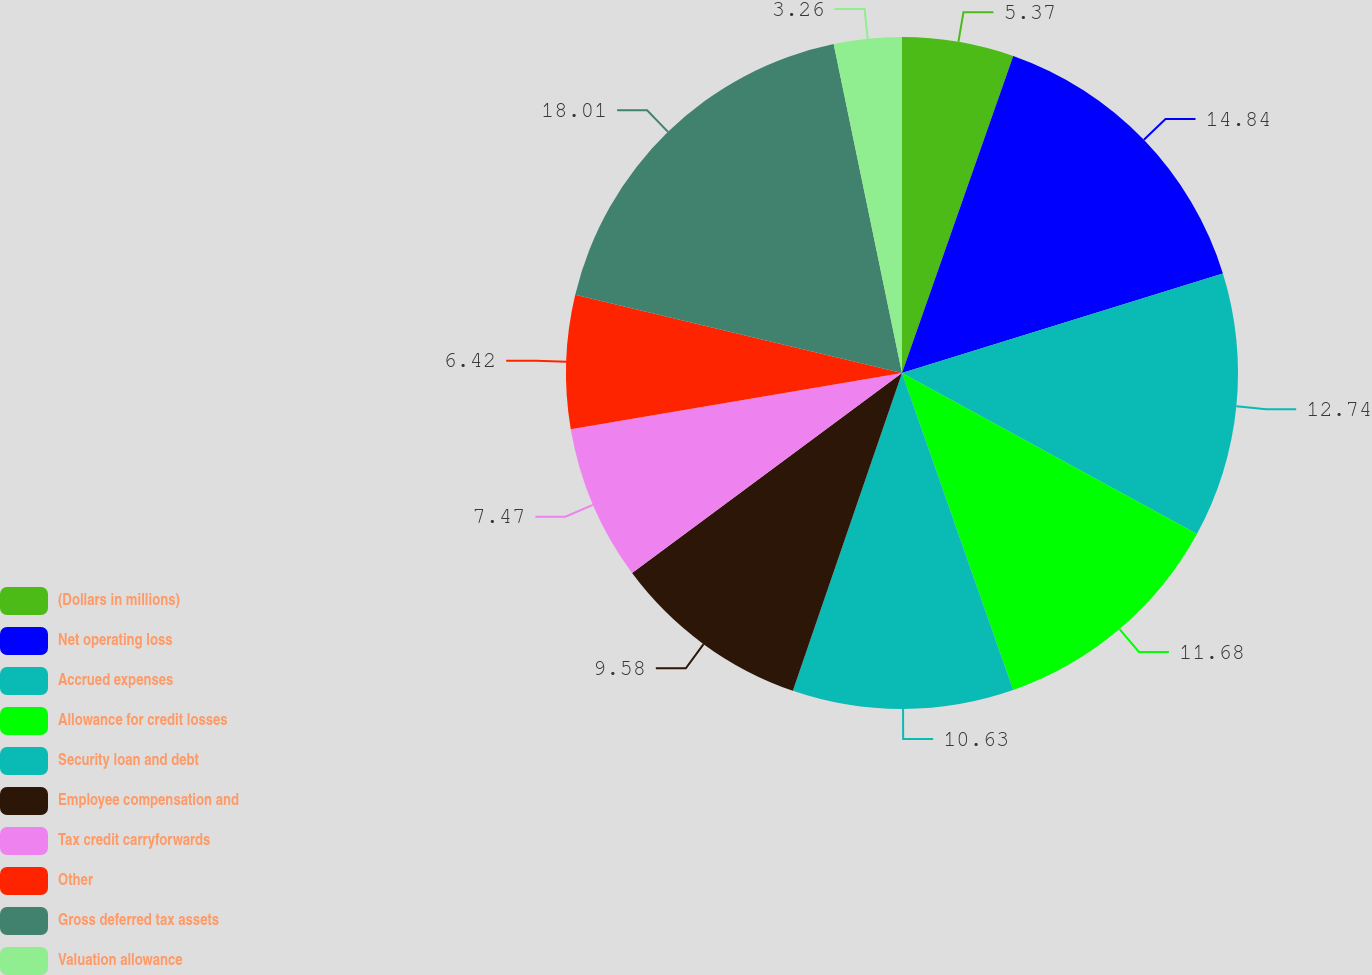<chart> <loc_0><loc_0><loc_500><loc_500><pie_chart><fcel>(Dollars in millions)<fcel>Net operating loss<fcel>Accrued expenses<fcel>Allowance for credit losses<fcel>Security loan and debt<fcel>Employee compensation and<fcel>Tax credit carryforwards<fcel>Other<fcel>Gross deferred tax assets<fcel>Valuation allowance<nl><fcel>5.37%<fcel>14.84%<fcel>12.74%<fcel>11.68%<fcel>10.63%<fcel>9.58%<fcel>7.47%<fcel>6.42%<fcel>18.0%<fcel>3.26%<nl></chart> 